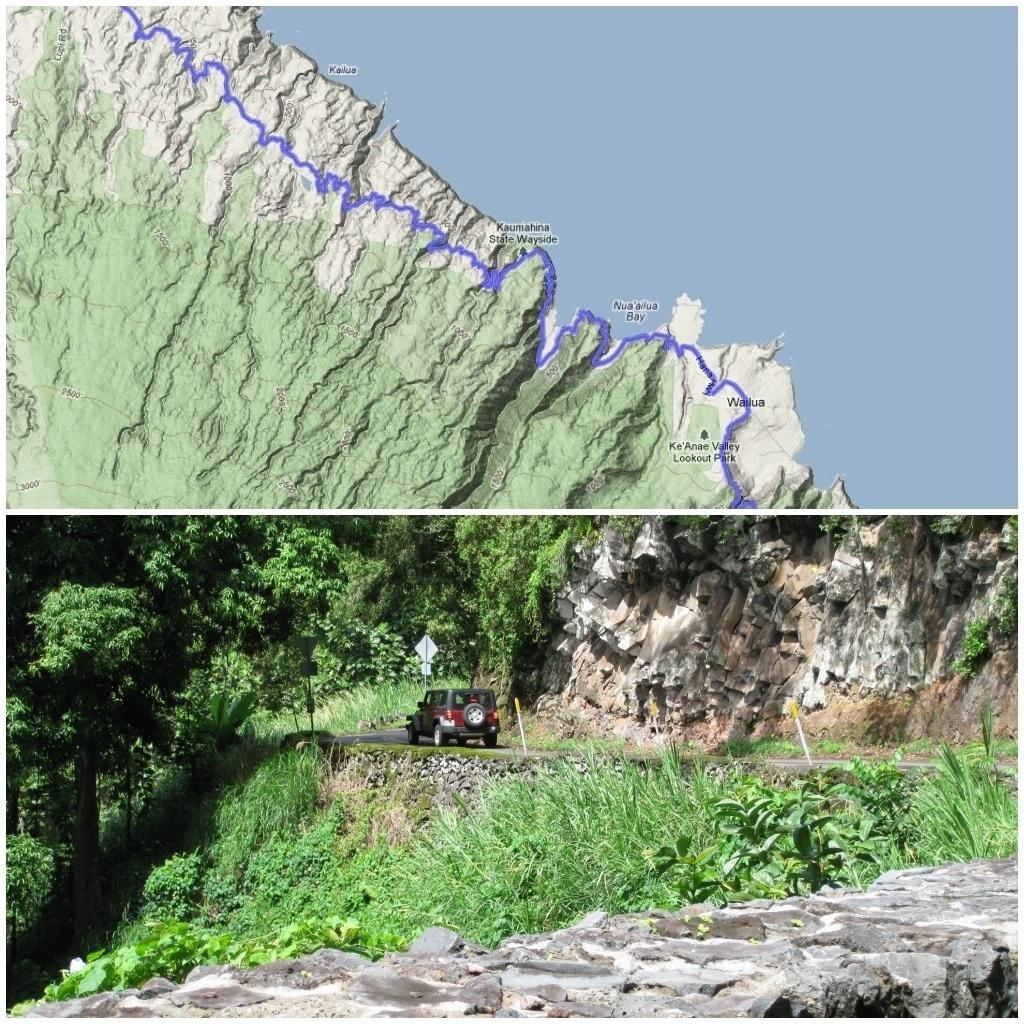What is the main subject of the image? There is a car on a road in the image. What can be seen in the background of the image? There are trees in the image. What additional item is present in the image? There is a map in the image. What type of quartz can be seen in the image? There is no quartz present in the image. What relation does the car have with the trees in the image? The car and trees are separate subjects in the image, and no direct relation between them is mentioned or implied. 